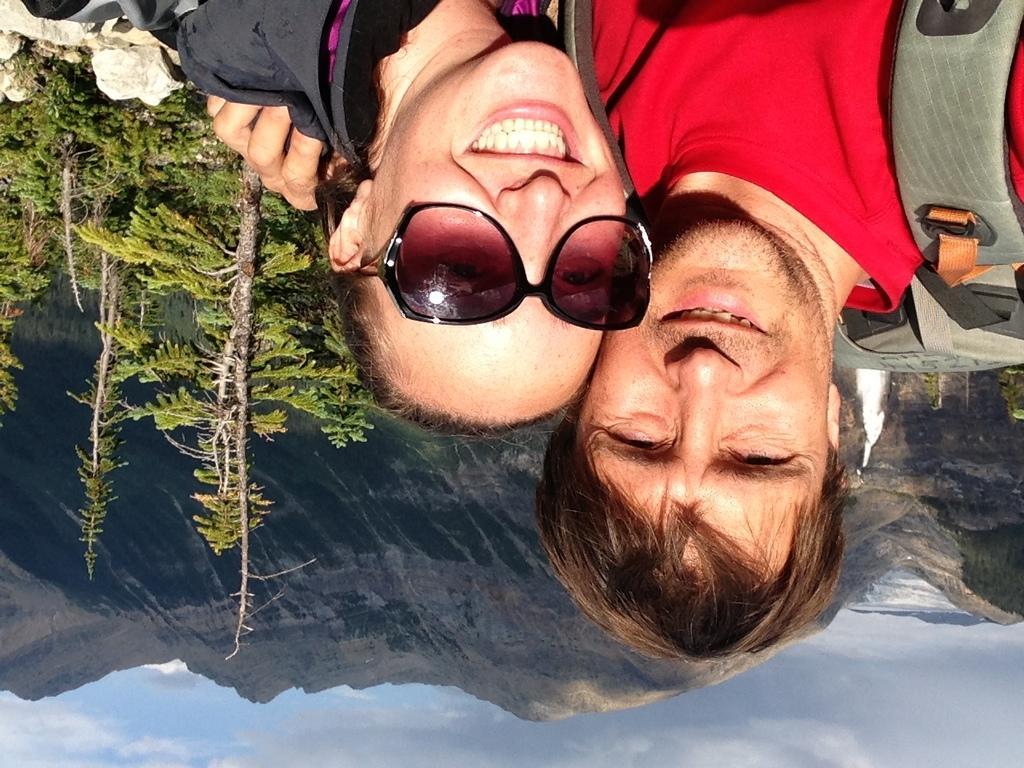Can you describe this image briefly? This image consists of two persons. To the left, there are trees. To the top left, there are rocks. At the bottom, there is a sky. In the background, there are mountains. 